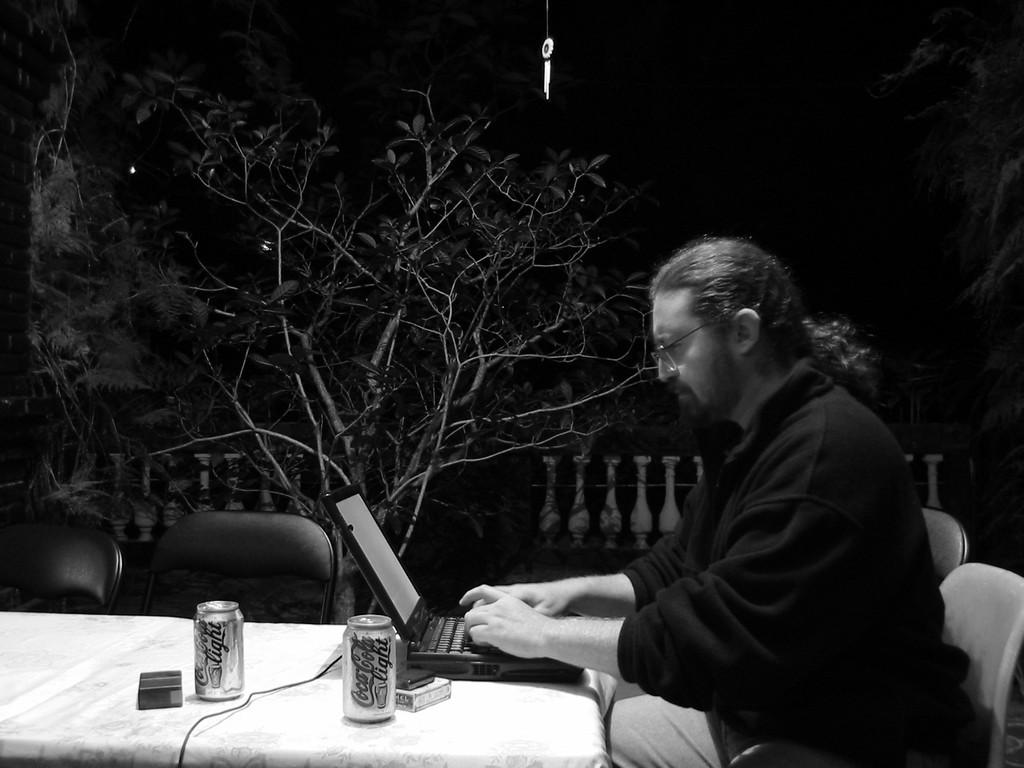What is the person in the image doing? The person is sitting and working on a laptop. What objects are on the table in the image? There are two tins on the table. What can be seen in the background of the image? Dried trees are visible in the background of the image. Is the person taking a bath in the image? No, the person is sitting and working on a laptop, not taking a bath. 